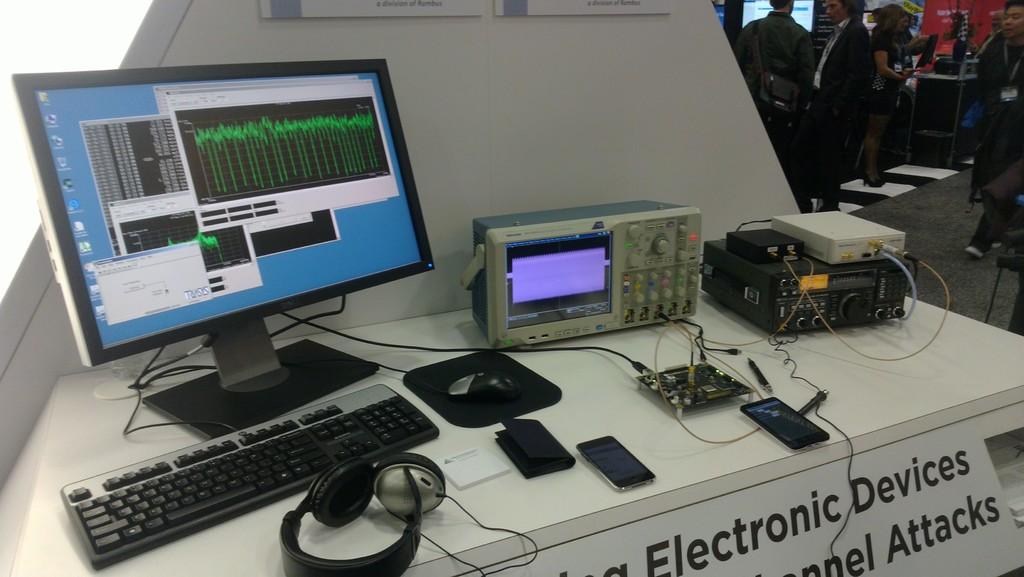What type of devices are these?
Make the answer very short. Electronic. 